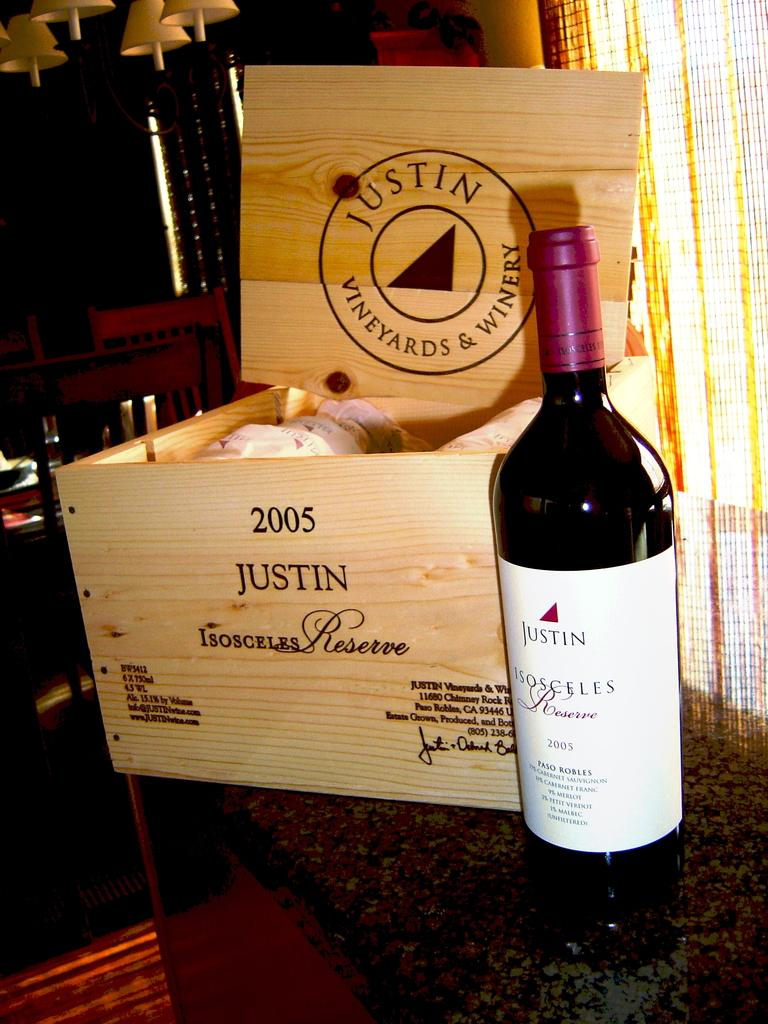<image>
Render a clear and concise summary of the photo. the name Justin is on the brown item on the table 